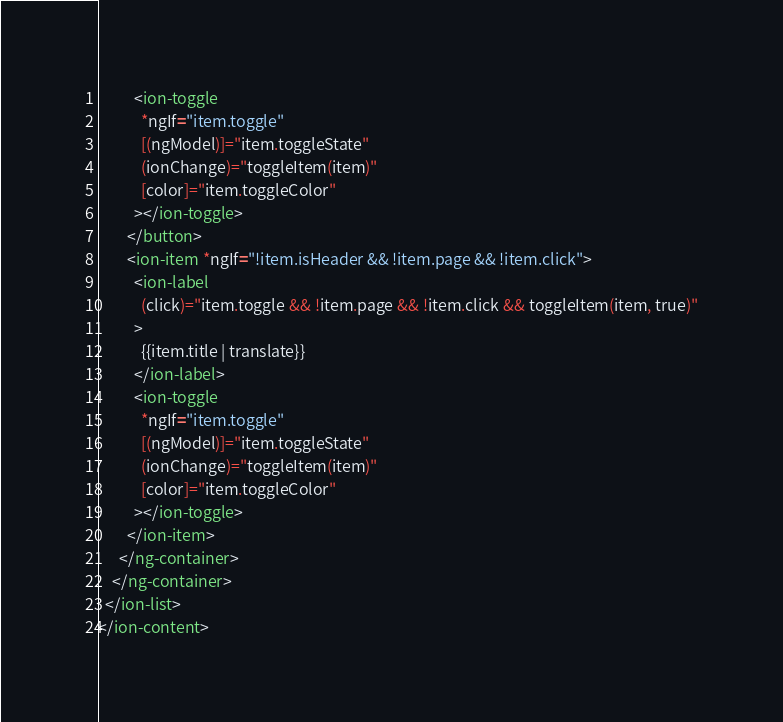Convert code to text. <code><loc_0><loc_0><loc_500><loc_500><_HTML_>          <ion-toggle
            *ngIf="item.toggle"
            [(ngModel)]="item.toggleState"
            (ionChange)="toggleItem(item)"
            [color]="item.toggleColor"
          ></ion-toggle>
        </button>
        <ion-item *ngIf="!item.isHeader && !item.page && !item.click">
          <ion-label
            (click)="item.toggle && !item.page && !item.click && toggleItem(item, true)"
          >
            {{item.title | translate}}
          </ion-label>
          <ion-toggle
            *ngIf="item.toggle"
            [(ngModel)]="item.toggleState"
            (ionChange)="toggleItem(item)"
            [color]="item.toggleColor"
          ></ion-toggle>
        </ion-item>
      </ng-container>
    </ng-container>
  </ion-list>
</ion-content>
</code> 